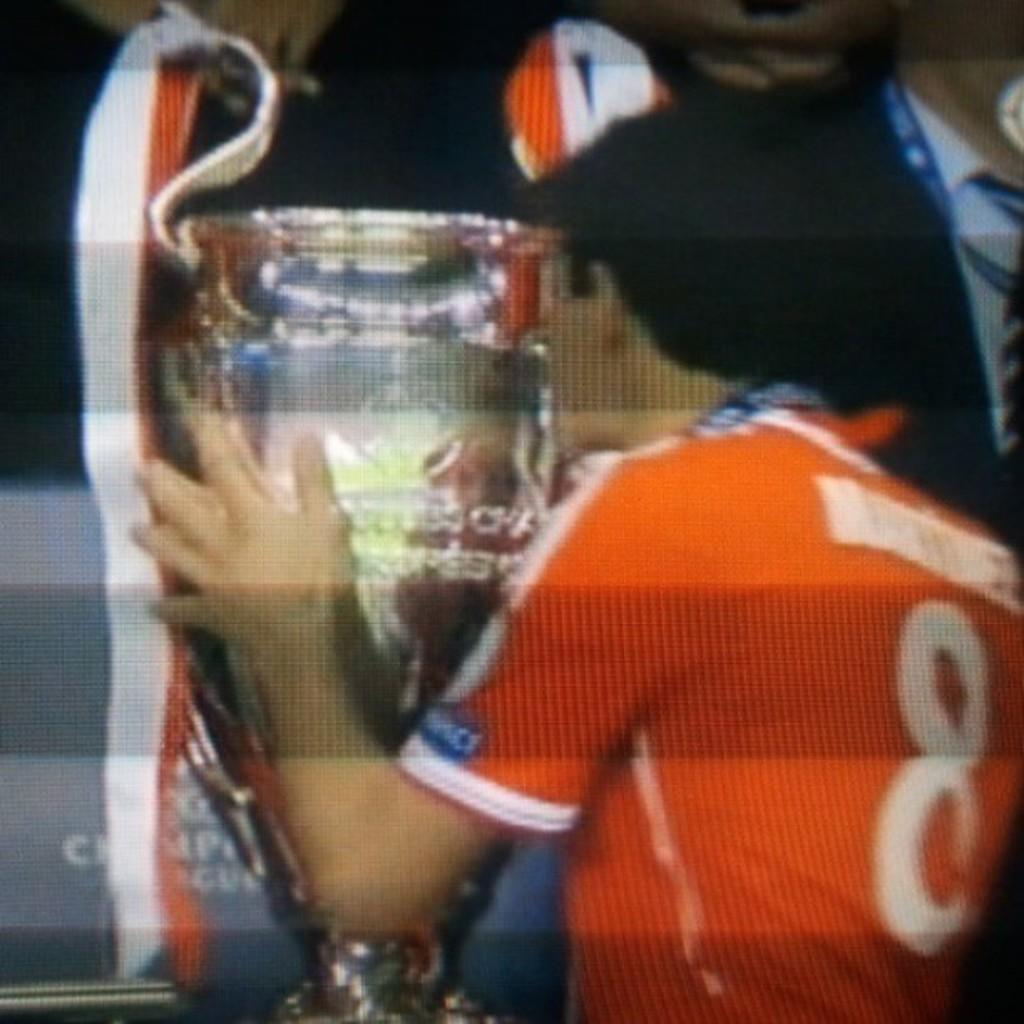<image>
Present a compact description of the photo's key features. The number 8 is on the back of a man's shirt. 